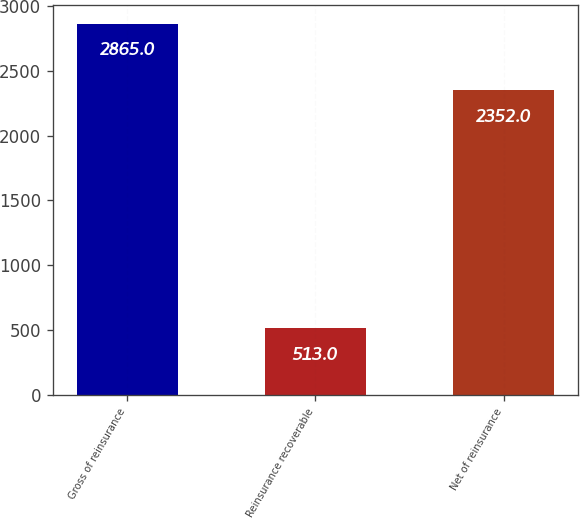<chart> <loc_0><loc_0><loc_500><loc_500><bar_chart><fcel>Gross of reinsurance<fcel>Reinsurance recoverable<fcel>Net of reinsurance<nl><fcel>2865<fcel>513<fcel>2352<nl></chart> 